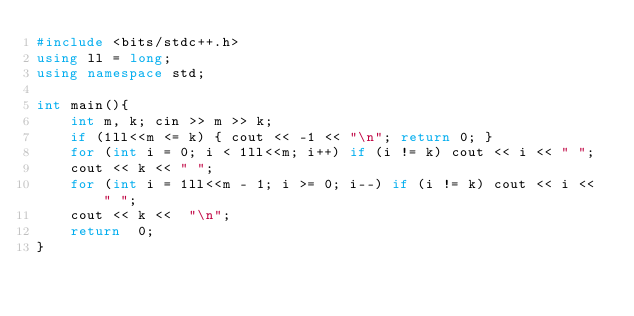Convert code to text. <code><loc_0><loc_0><loc_500><loc_500><_C++_>#include <bits/stdc++.h>
using ll = long;
using namespace std;

int main(){
    int m, k; cin >> m >> k;
    if (1ll<<m <= k) { cout << -1 << "\n"; return 0; }
    for (int i = 0; i < 1ll<<m; i++) if (i != k) cout << i << " ";
    cout << k << " ";
    for (int i = 1ll<<m - 1; i >= 0; i--) if (i != k) cout << i << " ";
    cout << k <<  "\n";
    return  0;
}</code> 